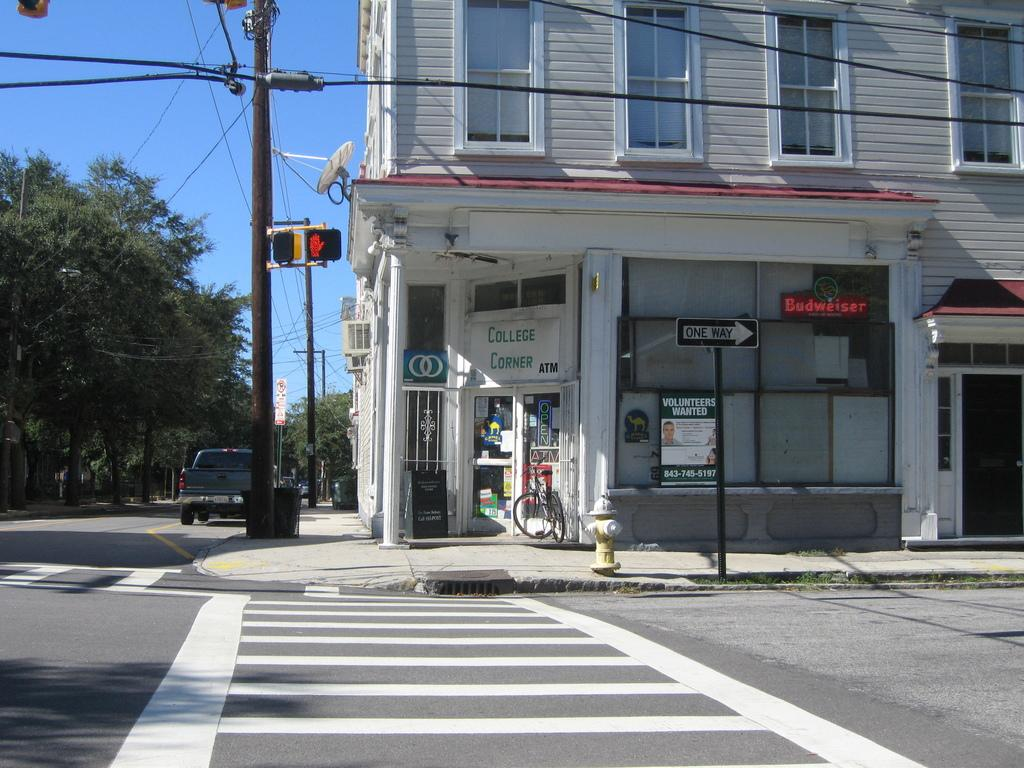<image>
Create a compact narrative representing the image presented. An establishment called college corner is sitting in the corner of an empty intersection. 